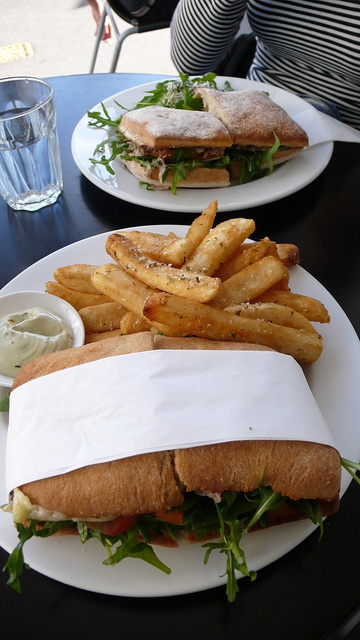Describe the objects in this image and their specific colors. I can see sandwich in lightgray, lavender, black, and maroon tones, dining table in lightgray, black, lightblue, navy, and darkblue tones, people in lightgray, black, gray, darkgray, and purple tones, sandwich in lightgray, black, olive, and darkgray tones, and cup in lightgray, darkgray, and gray tones in this image. 